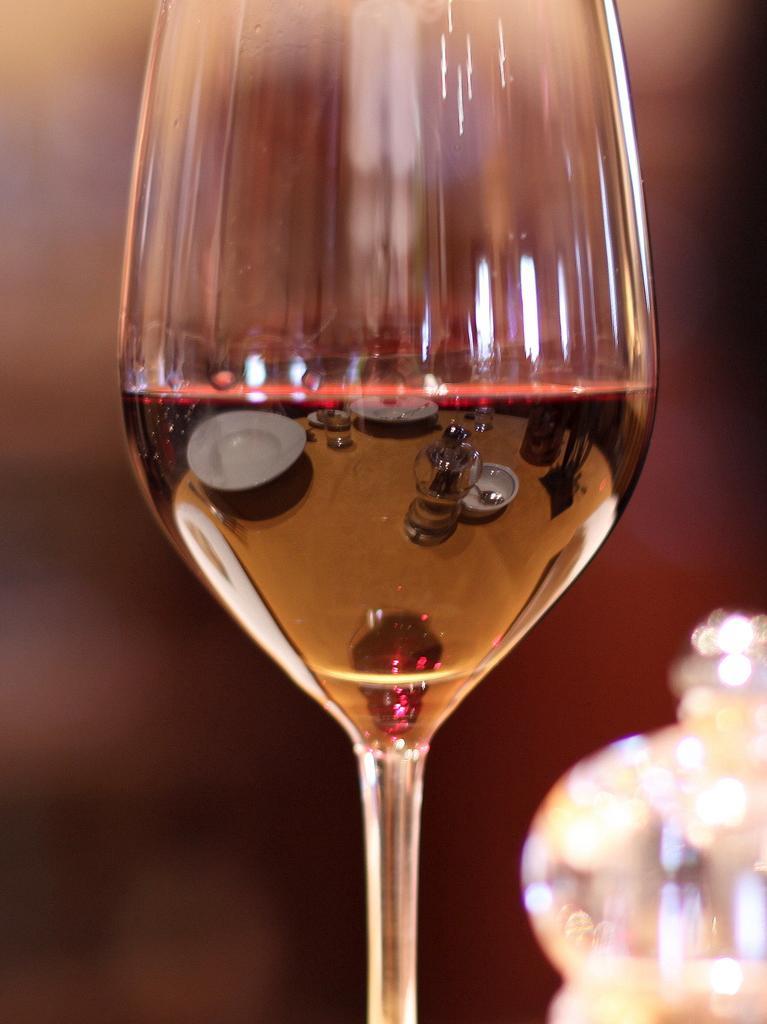Can you describe this image briefly? In this picture there is a glass in the center. 